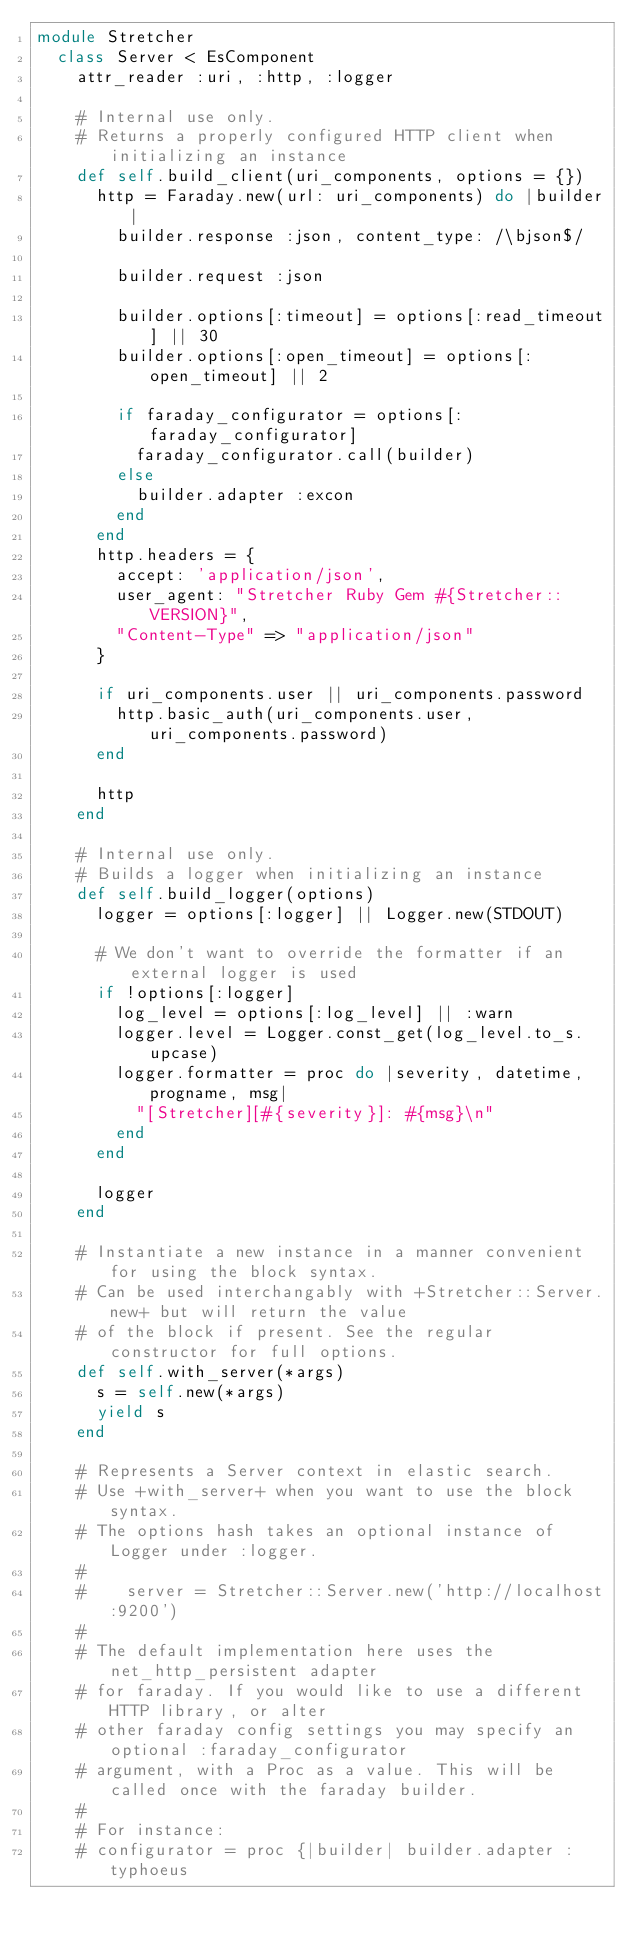<code> <loc_0><loc_0><loc_500><loc_500><_Ruby_>module Stretcher
  class Server < EsComponent
    attr_reader :uri, :http, :logger

    # Internal use only.
    # Returns a properly configured HTTP client when initializing an instance
    def self.build_client(uri_components, options = {})
      http = Faraday.new(url: uri_components) do |builder|
        builder.response :json, content_type: /\bjson$/

        builder.request :json

        builder.options[:timeout] = options[:read_timeout] || 30
        builder.options[:open_timeout] = options[:open_timeout] || 2

        if faraday_configurator = options[:faraday_configurator]
          faraday_configurator.call(builder)
        else
          builder.adapter :excon
        end
      end
      http.headers = {
        accept: 'application/json',
        user_agent: "Stretcher Ruby Gem #{Stretcher::VERSION}",
        "Content-Type" => "application/json"
      }

      if uri_components.user || uri_components.password
        http.basic_auth(uri_components.user, uri_components.password)
      end

      http
    end

    # Internal use only.
    # Builds a logger when initializing an instance
    def self.build_logger(options)
      logger = options[:logger] || Logger.new(STDOUT)

      # We don't want to override the formatter if an external logger is used
      if !options[:logger]
        log_level = options[:log_level] || :warn
        logger.level = Logger.const_get(log_level.to_s.upcase)
        logger.formatter = proc do |severity, datetime, progname, msg|
          "[Stretcher][#{severity}]: #{msg}\n"
        end
      end

      logger
    end

    # Instantiate a new instance in a manner convenient for using the block syntax.
    # Can be used interchangably with +Stretcher::Server.new+ but will return the value
    # of the block if present. See the regular constructor for full options.
    def self.with_server(*args)
      s = self.new(*args)
      yield s
    end

    # Represents a Server context in elastic search.
    # Use +with_server+ when you want to use the block syntax.
    # The options hash takes an optional instance of Logger under :logger.
    #
    #    server = Stretcher::Server.new('http://localhost:9200')
    #
    # The default implementation here uses the net_http_persistent adapter
    # for faraday. If you would like to use a different HTTP library, or alter
    # other faraday config settings you may specify an optional :faraday_configurator
    # argument, with a Proc as a value. This will be called once with the faraday builder.
    #
    # For instance:
    # configurator = proc {|builder| builder.adapter :typhoeus</code> 